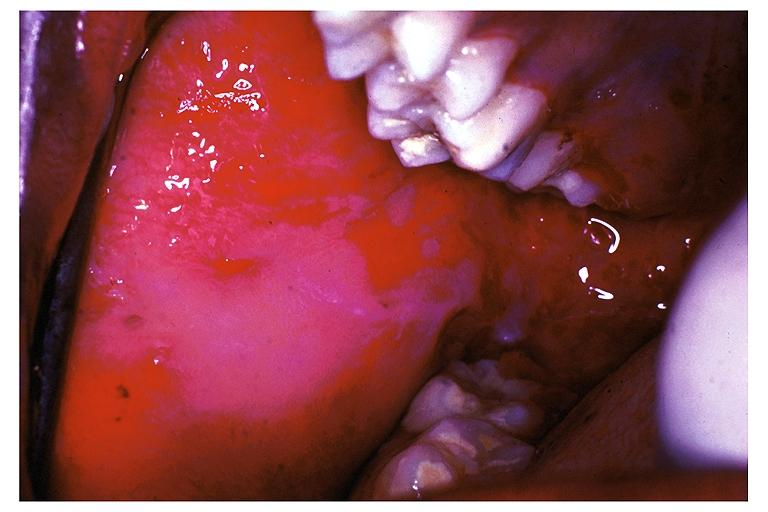where is this?
Answer the question using a single word or phrase. Oral 